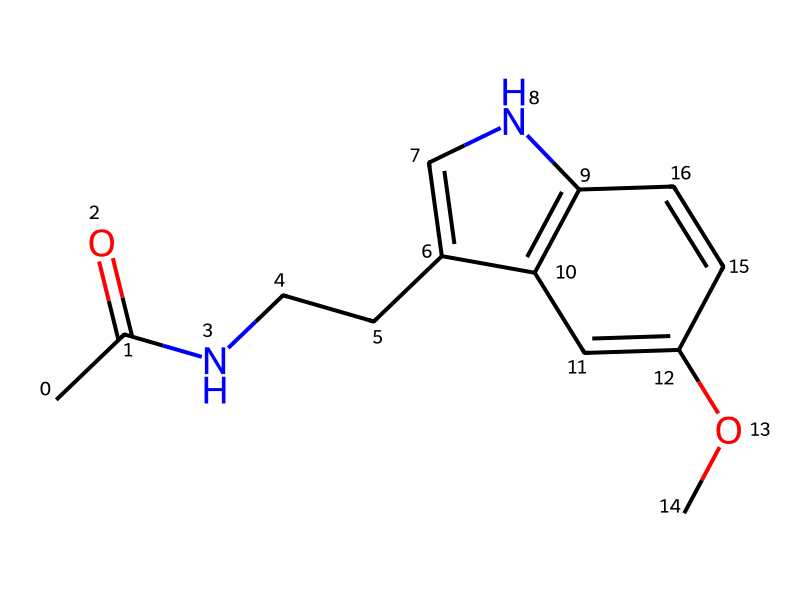What is the molecular formula of melatonin? To determine the molecular formula, we need to count the number of each type of atom present in the chemical structure represented by the SMILES notation. From the structure, we have 13 carbon (C) atoms, 16 hydrogen (H) atoms, 2 nitrogen (N) atoms, and 2 oxygen (O) atoms. Therefore, the molecular formula combines these counts as C13H16N2O2.
Answer: C13H16N2O2 How many nitrogen atoms are in the structure? By analyzing the SMILES representation, we can identify nitrogen (N) atoms. In the given structure, there are two nitrogen atoms indicated.
Answer: 2 What type of functional groups are present in melatonin? The structure of melatonin contains several functional groups, including an amide (CC(=O)N) and a methoxy group (OC). Identifying these groups helps in understanding the chemical properties of melatonin.
Answer: amide and methoxy What is the significance of the indole structure in melatonin? The indole structure contributes to melatonin's role as a neurotransmitter and in regulating sleep-wake cycles. The bicyclic structure of indole is crucial for its biological activity and interaction with receptors.
Answer: neurotransmitter How many rings are present in the chemical structure of melatonin? The SMILES structure reveals a bicyclic structure formed by the indole moiety, which consists of two fused rings. This is characteristic of melatonin and contributes to its biological functions.
Answer: 2 What makes melatonin a hormone? Melatonin is classified as a hormone because it is produced by the pineal gland, regulates circadian rhythms, and is secreted in response to environmental light. Its actions influence sleep patterns and the sleep-wake cycle.
Answer: regulates sleep 